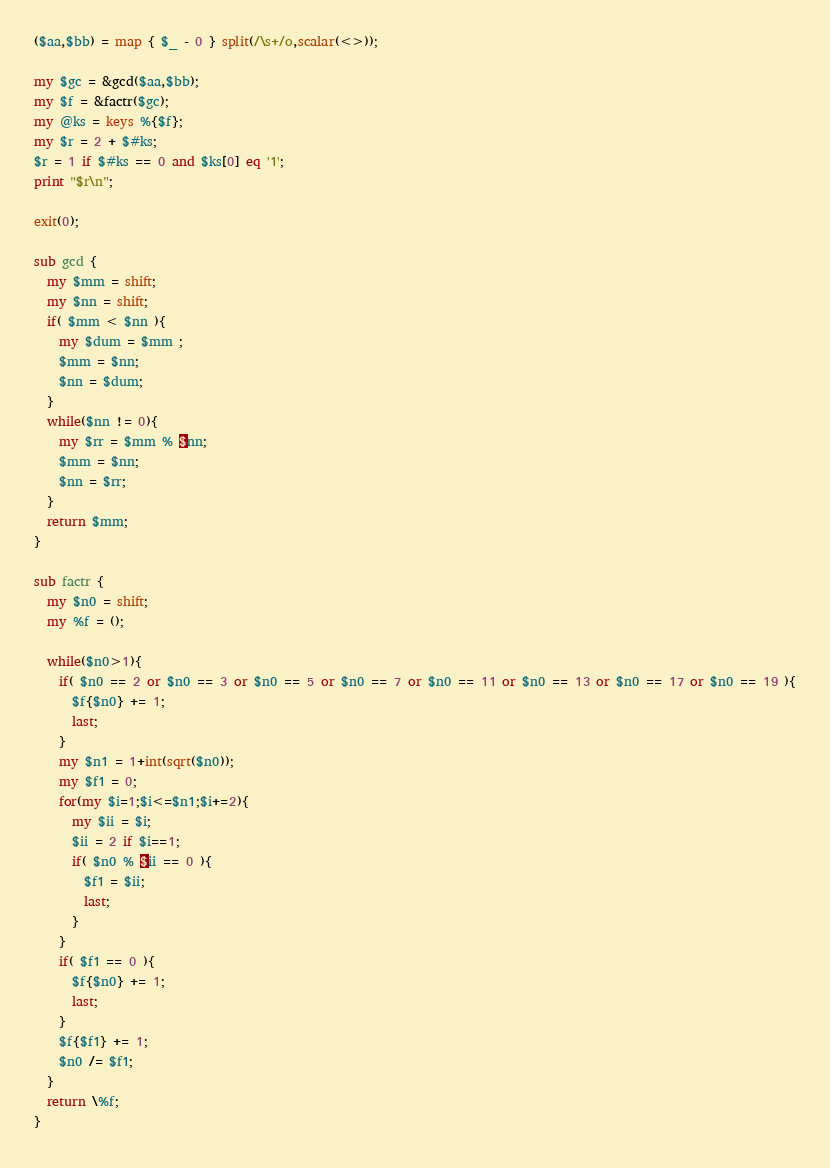Convert code to text. <code><loc_0><loc_0><loc_500><loc_500><_Perl_>($aa,$bb) = map { $_ - 0 } split(/\s+/o,scalar(<>));

my $gc = &gcd($aa,$bb);
my $f = &factr($gc);
my @ks = keys %{$f};
my $r = 2 + $#ks;
$r = 1 if $#ks == 0 and $ks[0] eq '1';
print "$r\n";

exit(0);

sub gcd {
  my $mm = shift;
  my $nn = shift;
  if( $mm < $nn ){
    my $dum = $mm ;
    $mm = $nn;
    $nn = $dum;
  }
  while($nn != 0){
    my $rr = $mm % $nn;
    $mm = $nn;
    $nn = $rr;
  }
  return $mm;
}

sub factr {
  my $n0 = shift;
  my %f = ();
  
  while($n0>1){
    if( $n0 == 2 or $n0 == 3 or $n0 == 5 or $n0 == 7 or $n0 == 11 or $n0 == 13 or $n0 == 17 or $n0 == 19 ){
      $f{$n0} += 1;
      last;
    }
    my $n1 = 1+int(sqrt($n0));
    my $f1 = 0;
    for(my $i=1;$i<=$n1;$i+=2){
      my $ii = $i;
      $ii = 2 if $i==1;
      if( $n0 % $ii == 0 ){
        $f1 = $ii;
        last;
      }
    }
    if( $f1 == 0 ){
      $f{$n0} += 1;
      last;
    }
    $f{$f1} += 1;
    $n0 /= $f1;
  }
  return \%f;
}

</code> 